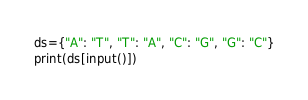Convert code to text. <code><loc_0><loc_0><loc_500><loc_500><_Python_>ds={"A": "T", "T": "A", "C": "G", "G": "C"}
print(ds[input()])</code> 